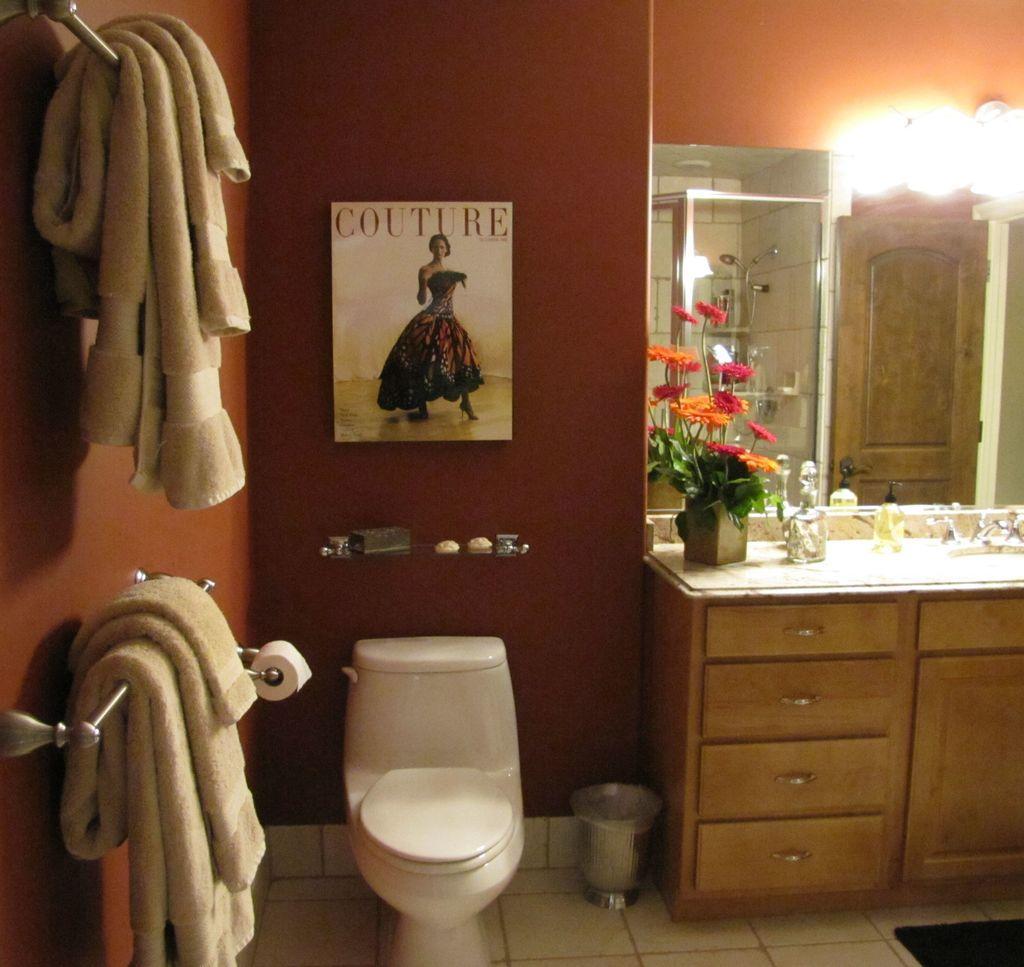Describe this image in one or two sentences. On the left side, there are towels on the hangers which are attached to the brown color wall. In the background, there is a white color toilet which is on the floor near a dustbin. There is a photo frame on the wall, there is a mirror near a table on which, there is a flower vase and other objects. And this table is having wooden cupboards. 